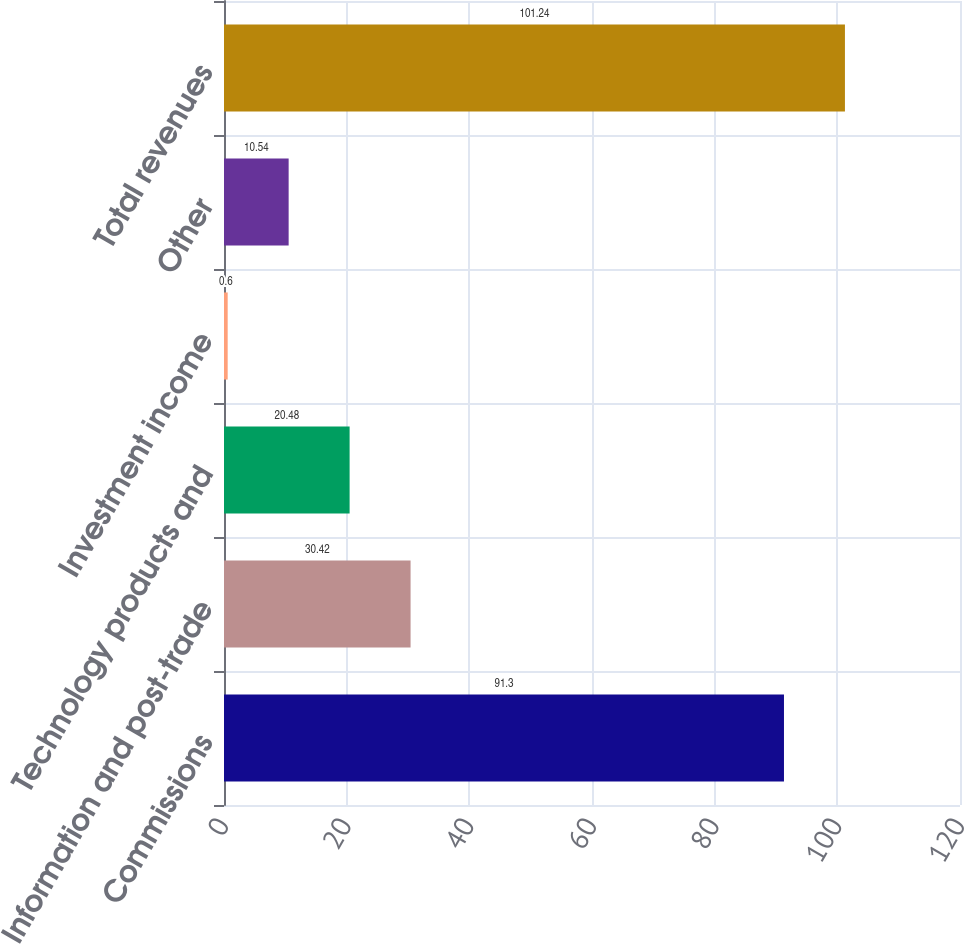Convert chart to OTSL. <chart><loc_0><loc_0><loc_500><loc_500><bar_chart><fcel>Commissions<fcel>Information and post-trade<fcel>Technology products and<fcel>Investment income<fcel>Other<fcel>Total revenues<nl><fcel>91.3<fcel>30.42<fcel>20.48<fcel>0.6<fcel>10.54<fcel>101.24<nl></chart> 